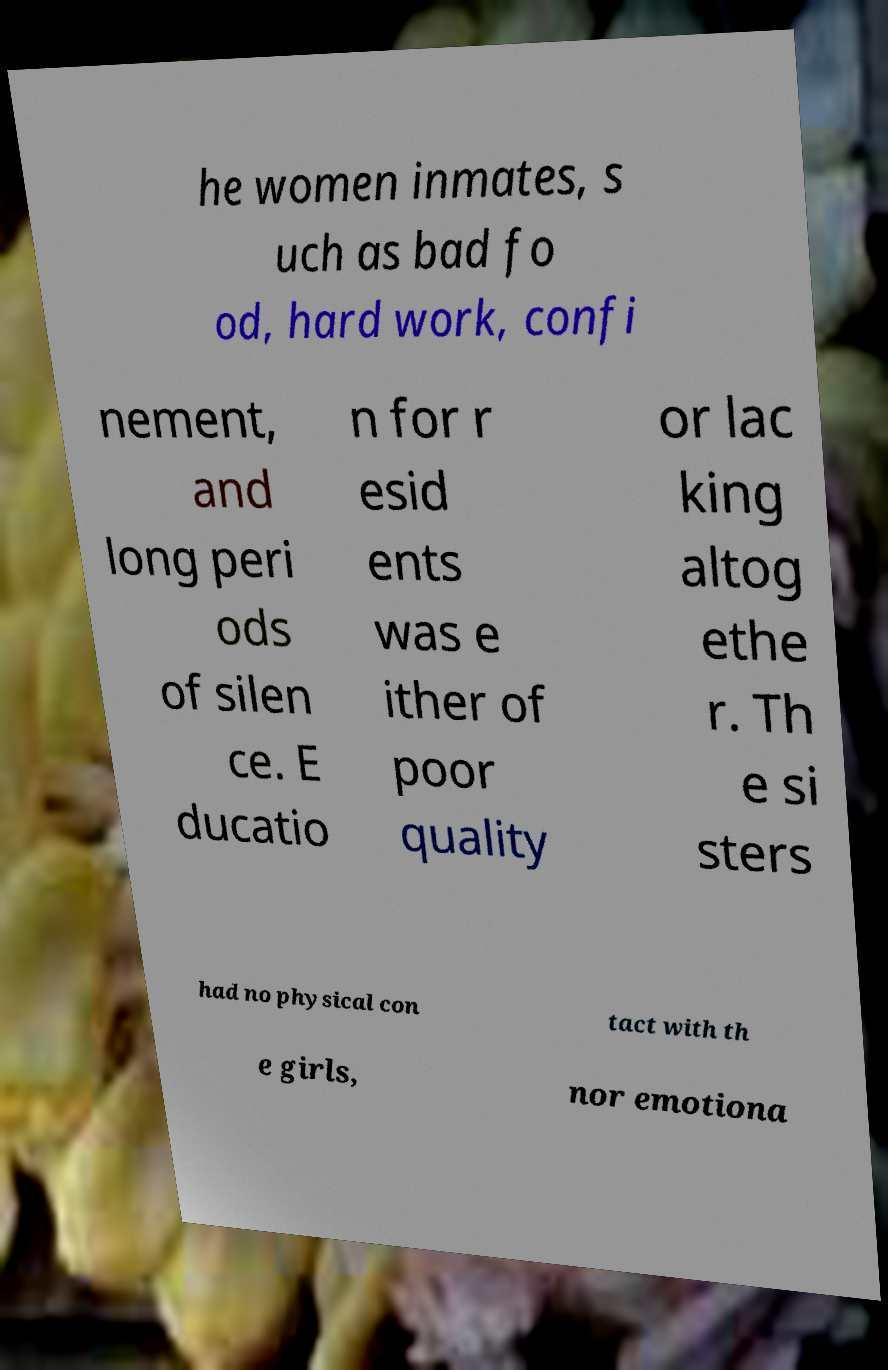Could you extract and type out the text from this image? he women inmates, s uch as bad fo od, hard work, confi nement, and long peri ods of silen ce. E ducatio n for r esid ents was e ither of poor quality or lac king altog ethe r. Th e si sters had no physical con tact with th e girls, nor emotiona 